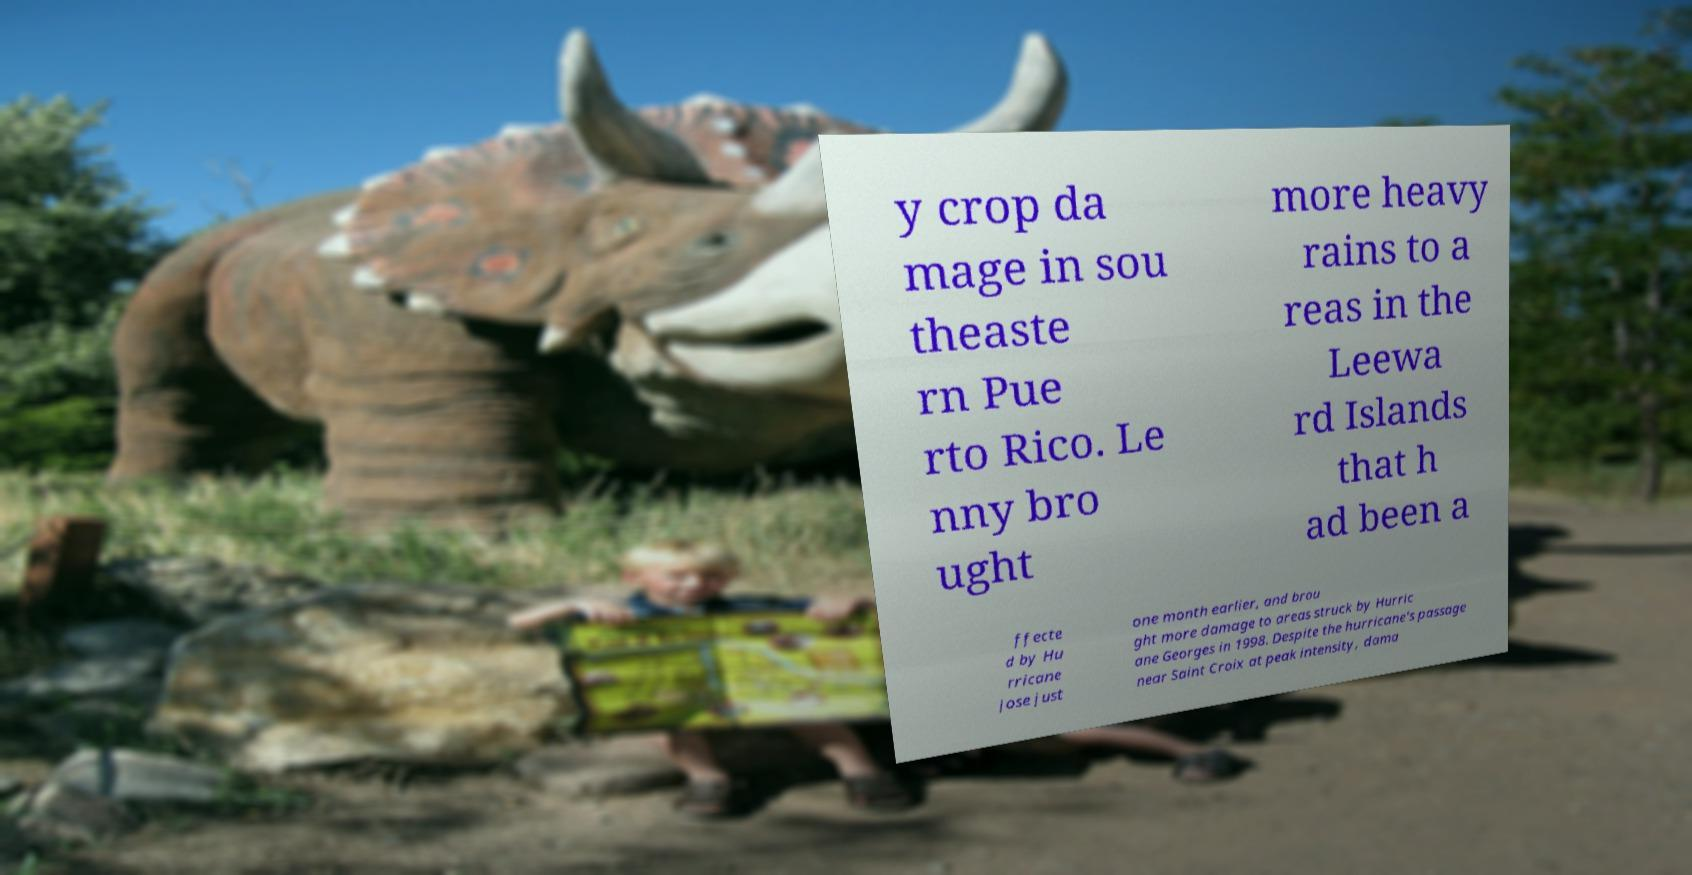What messages or text are displayed in this image? I need them in a readable, typed format. y crop da mage in sou theaste rn Pue rto Rico. Le nny bro ught more heavy rains to a reas in the Leewa rd Islands that h ad been a ffecte d by Hu rricane Jose just one month earlier, and brou ght more damage to areas struck by Hurric ane Georges in 1998. Despite the hurricane's passage near Saint Croix at peak intensity, dama 